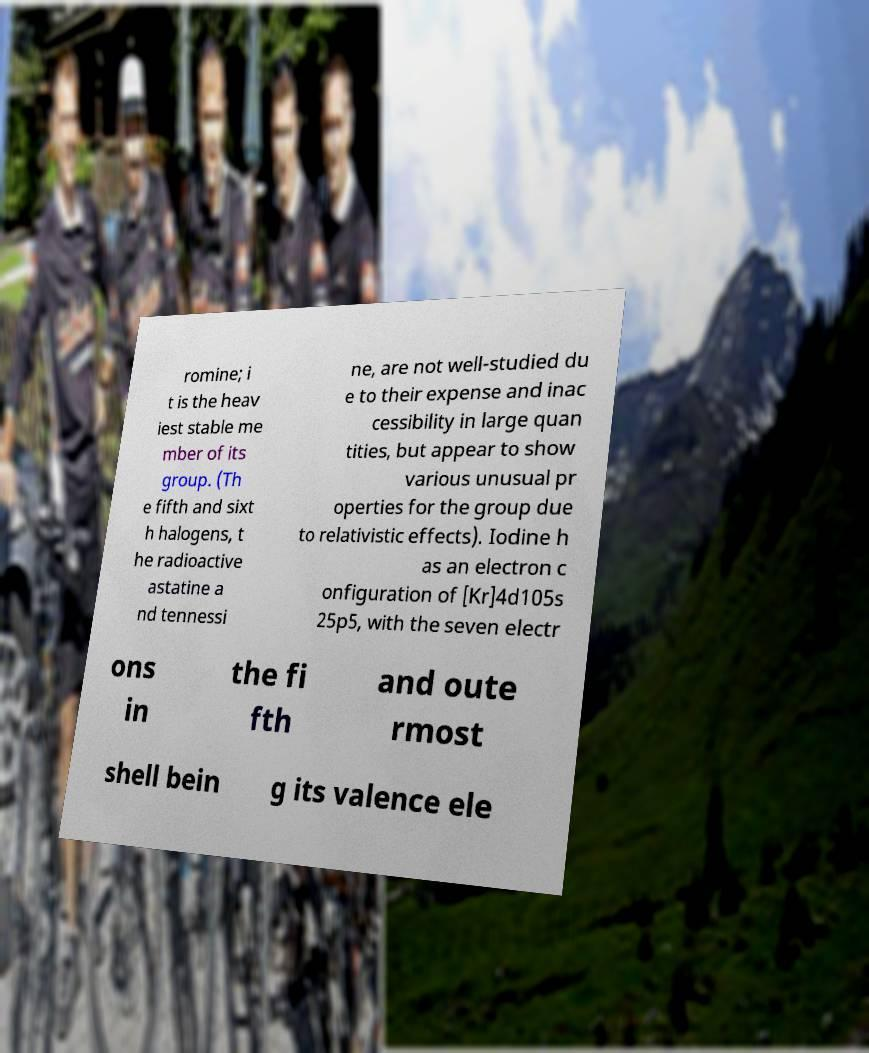For documentation purposes, I need the text within this image transcribed. Could you provide that? romine; i t is the heav iest stable me mber of its group. (Th e fifth and sixt h halogens, t he radioactive astatine a nd tennessi ne, are not well-studied du e to their expense and inac cessibility in large quan tities, but appear to show various unusual pr operties for the group due to relativistic effects). Iodine h as an electron c onfiguration of [Kr]4d105s 25p5, with the seven electr ons in the fi fth and oute rmost shell bein g its valence ele 